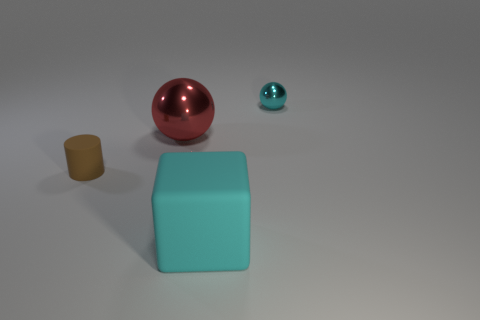Add 3 metal cylinders. How many objects exist? 7 Subtract all blue cubes. Subtract all red spheres. How many cubes are left? 1 Subtract all tiny brown things. Subtract all cubes. How many objects are left? 2 Add 2 small matte objects. How many small matte objects are left? 3 Add 3 brown objects. How many brown objects exist? 4 Subtract 0 purple balls. How many objects are left? 4 Subtract all cylinders. How many objects are left? 3 